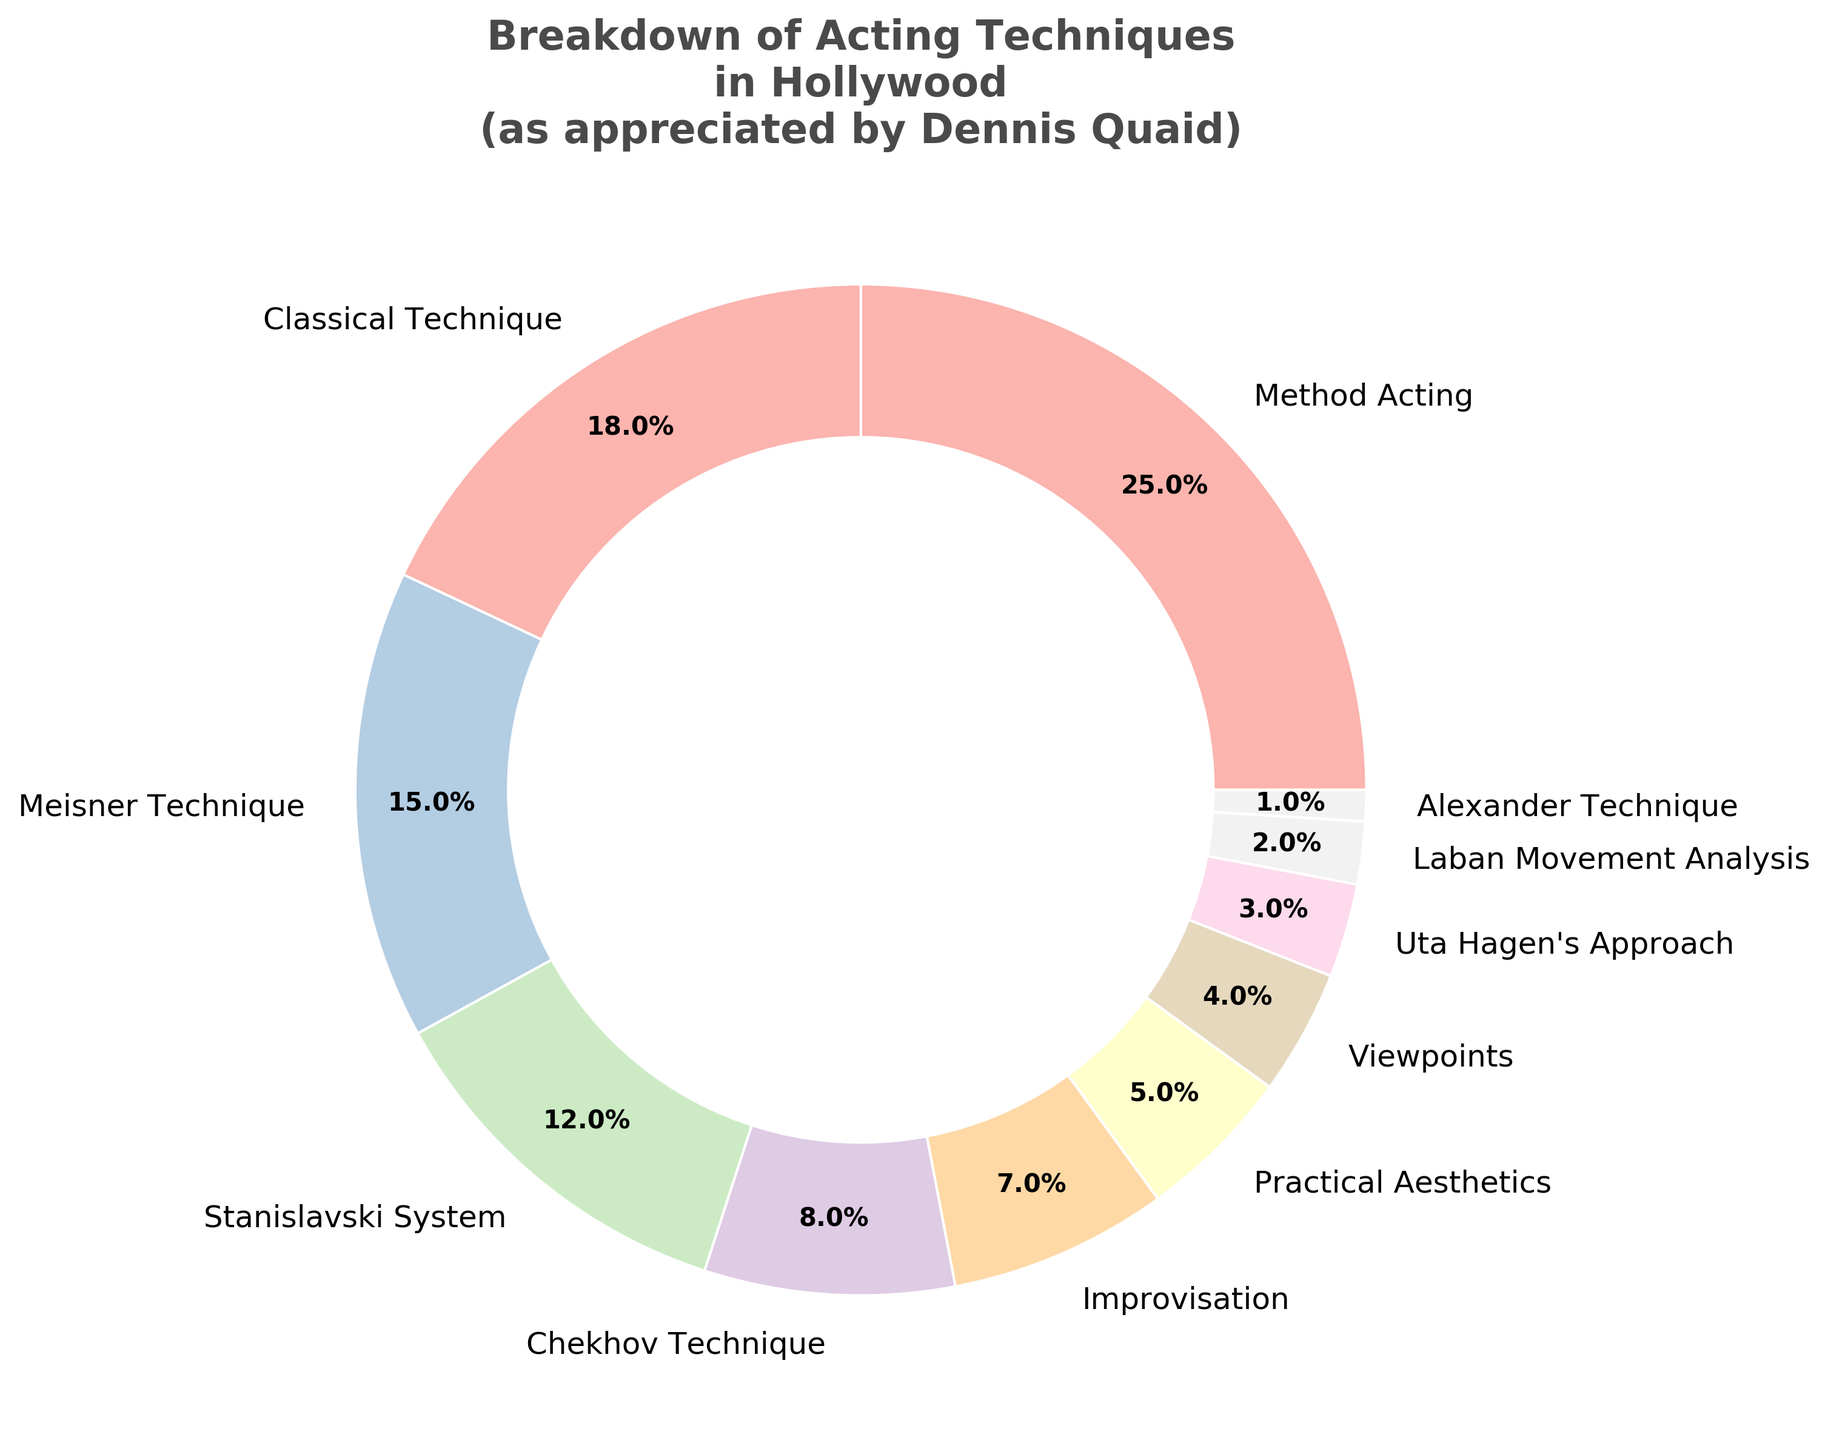Which acting technique has the highest percentage? The figure shows different acting techniques and their respective percentages. The largest slice is labeled "Method Acting" with 25%.
Answer: Method Acting What is the combined percentage of Classical Technique and Meisner Technique? The figure shows percentages for each technique. Adding Classical Technique (18%) and Meisner Technique (15%) gives 18 + 15 = 33.
Answer: 33% Which technique is used less, Uta Hagen's Approach or Laban Movement Analysis? Uta Hagen's Approach has 3% and Laban Movement Analysis has 2%. Since 2% is less than 3%, Laban Movement Analysis is used less.
Answer: Laban Movement Analysis How many techniques are used by less than 10% of successful actors? Techniques with slices less than 10% are Chekhov Technique (8%), Improvisation (7%), Practical Aesthetics (5%), Viewpoints (4%), Uta Hagen's Approach (3%), Laban Movement Analysis (2%), and Alexander Technique (1%). This totals 7 techniques.
Answer: 7 Which technique occupies the smallest slice in the pie chart? The smallest slice in the pie chart is labeled "Alexander Technique" with 1%.
Answer: Alexander Technique What is the difference in percentage between Method Acting and the Stanislavski System? Method Acting is 25% and the Stanislavski System is 12%. The difference is 25 - 12 = 13.
Answer: 13% How do the percentages of Meisner Technique and Classical Technique compare? The figure shows Meisner Technique at 15% and Classical Technique at 18%. Since 18% is greater than 15%, Classical Technique is used more.
Answer: Classical Technique is used more What is the total percentage for techniques grouped under improvisational methods (Improvisation, Viewpoints, Practical Aesthetics)? Improvisation (7%), Viewpoints (4%), and Practical Aesthetics (5%) sum to 7 + 4 + 5 = 16.
Answer: 16% Which slice in the pie chart is visually the third largest? The third largest slice after Method Acting (25%) and Classical Technique (18%) is the Meisner Technique with 15%.
Answer: Meisner Technique 